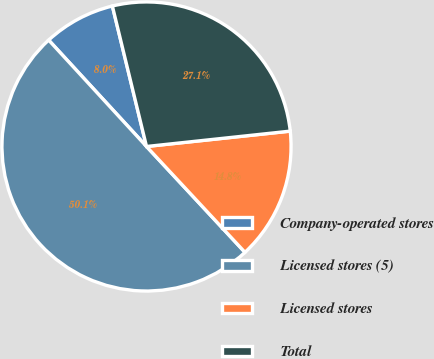Convert chart to OTSL. <chart><loc_0><loc_0><loc_500><loc_500><pie_chart><fcel>Company-operated stores<fcel>Licensed stores (5)<fcel>Licensed stores<fcel>Total<nl><fcel>8.04%<fcel>50.09%<fcel>14.77%<fcel>27.1%<nl></chart> 